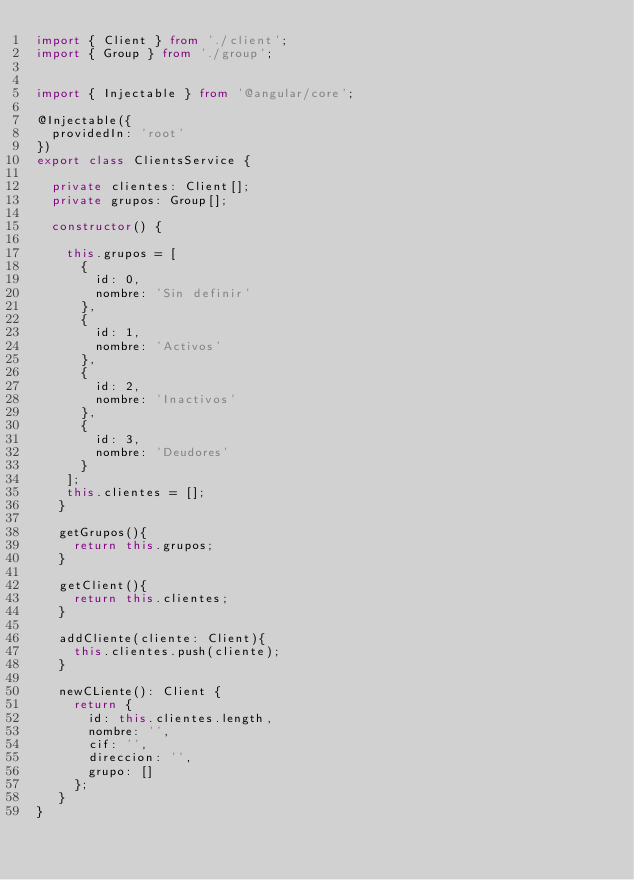<code> <loc_0><loc_0><loc_500><loc_500><_TypeScript_>import { Client } from './client';
import { Group } from './group';


import { Injectable } from '@angular/core';

@Injectable({
  providedIn: 'root'
})
export class ClientsService {

  private clientes: Client[];
  private grupos: Group[];

  constructor() {

    this.grupos = [
      {
        id: 0,
        nombre: 'Sin definir'
      },
      {
        id: 1,
        nombre: 'Activos'
      },
      {
        id: 2,
        nombre: 'Inactivos'
      },
      {
        id: 3,
        nombre: 'Deudores'
      }
    ];
    this.clientes = [];
   }

   getGrupos(){
     return this.grupos;
   }

   getClient(){
     return this.clientes;
   }

   addCliente(cliente: Client){
     this.clientes.push(cliente);
   }

   newCLiente(): Client {
     return {
       id: this.clientes.length,
       nombre: '',
       cif: '',
       direccion: '',
       grupo: []
     };
   }
}
</code> 